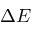Convert formula to latex. <formula><loc_0><loc_0><loc_500><loc_500>\Delta E</formula> 